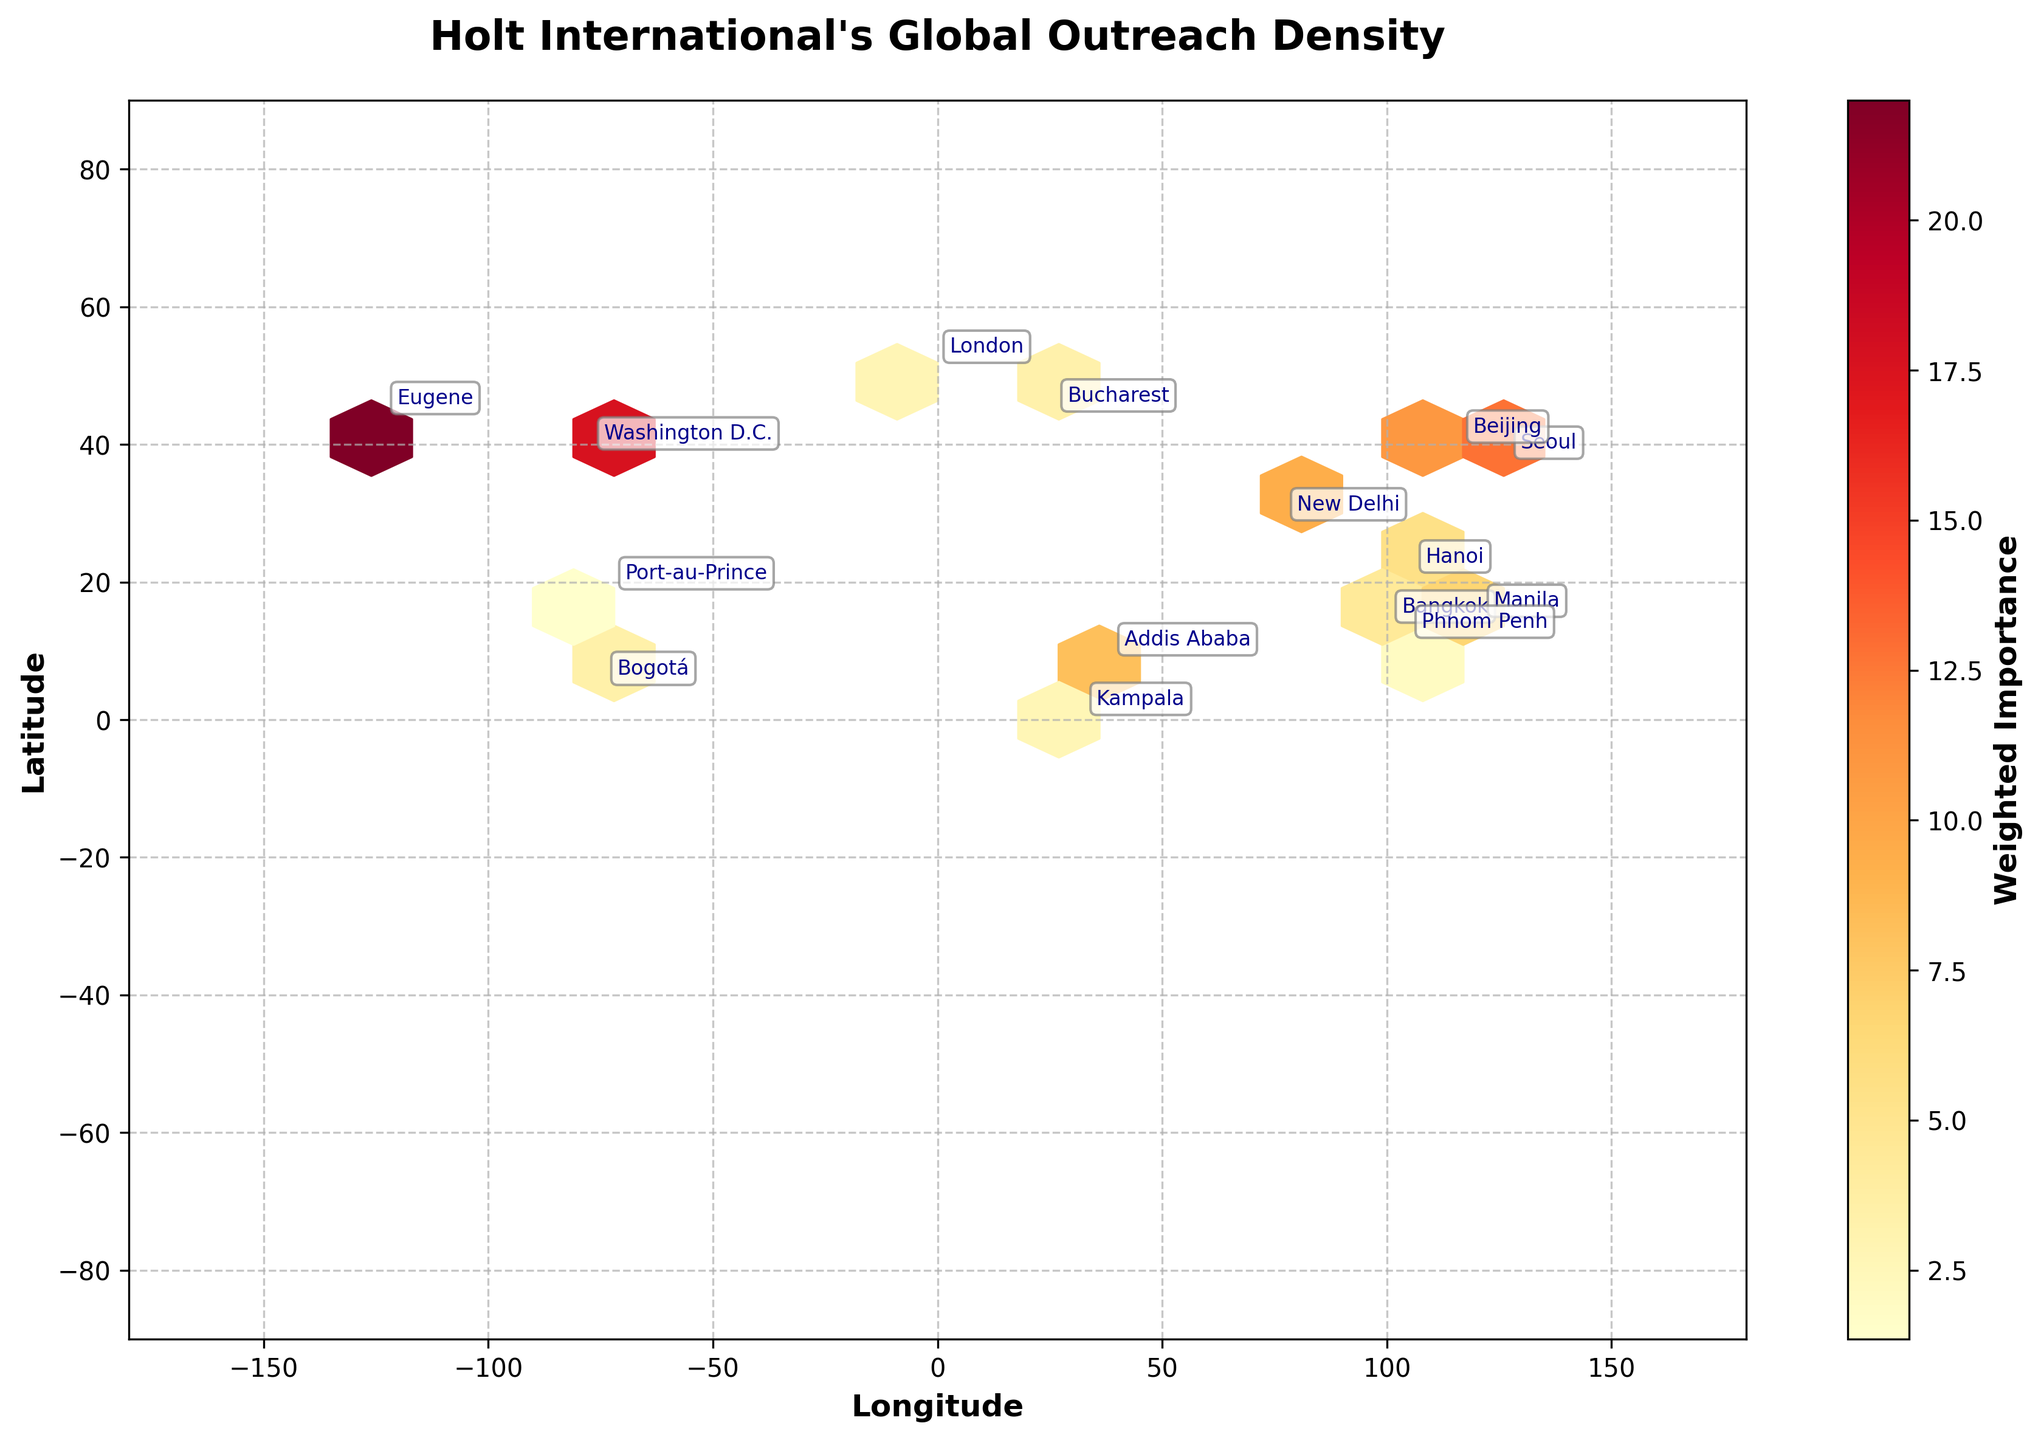What's the title of the plot? The title is always at the top of the plot and is usually larger in font compared to other text. The title provides a summary of what the plot is about.
Answer: Holt International's Global Outreach Density What does the color represent in the hexbin plot? In a hexbin plot, the color intensity often represents the concentration of specific values. In this case, the color represents the "Weighted Importance," which combines Staff_Count and Resource_Allocation.
Answer: Weighted Importance Which city has the highest concentration of resources and staff? Look for the city label located in the darkest hexagon cell, indicating the highest concentration of resources and staff.
Answer: Eugene What's the range of latitudes covered in the plot? The y-axis represents latitude, and you can find the range on the axis itself.
Answer: -90 to 90 Which regions in the plot are closest to the equator? The equator is at 0° latitude, so look for cities near the center horizontal line of the plot.
Answer: Kampala, Bogotá What's the weighted importance value of Seoul compared to Washington D.C.? Calculate the weighted importance for both cities. Seoul: 15 * 850000 / 1e6 = 12.75, Washington D.C.: 18 * 980000 / 1e6 = 17.64. Then, compare the values.
Answer: Washington D.C. has a higher weighted importance How many regions are located in Europe? Identify the cities in Europe and count them. The European cities are Bucharest and London.
Answer: 2 What is the grid size used in this hexbin plot? Grid size is often defined in the plot's parameters. It's indicated in the explanation of the plot.
Answer: 20 Why is Beijing's weighted importance higher than that of Kampala? Calculate the weighted importance for each city. Beijing: 14 * 780000 / 1e6 = 10.92, Kampala: 7 * 380000 / 1e6 = 2.66. Compare both values.
Answer: Beijing has a higher weighted importance due to higher staff count and resources 